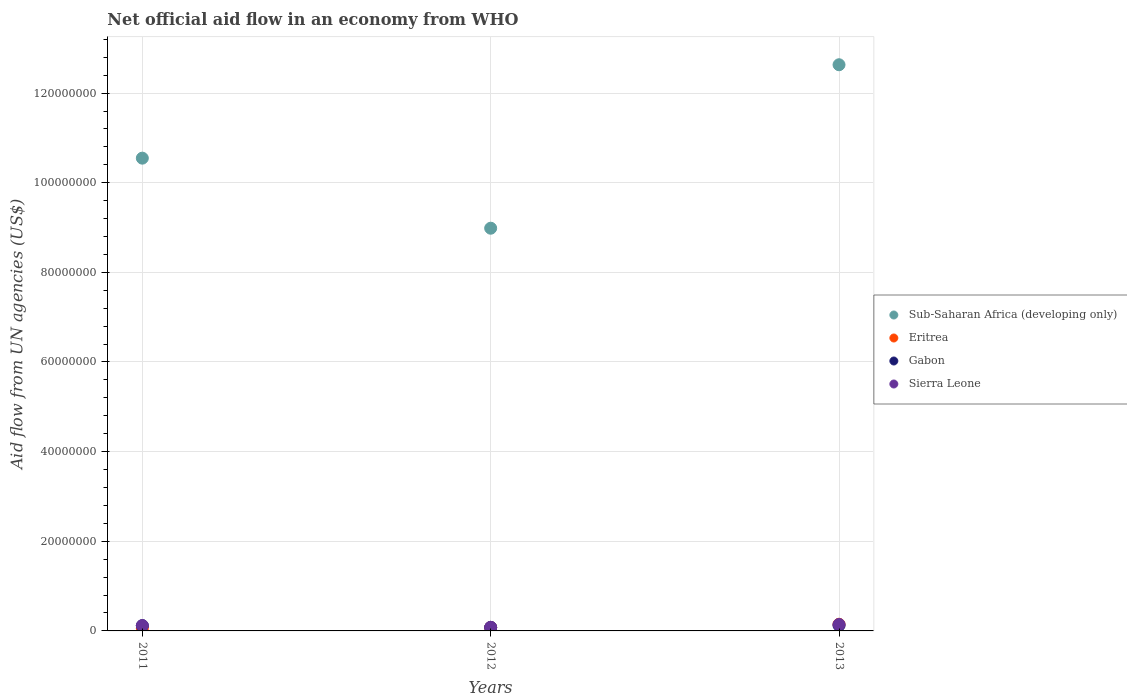Is the number of dotlines equal to the number of legend labels?
Offer a very short reply. Yes. What is the net official aid flow in Sub-Saharan Africa (developing only) in 2011?
Provide a succinct answer. 1.05e+08. Across all years, what is the maximum net official aid flow in Sub-Saharan Africa (developing only)?
Offer a terse response. 1.26e+08. Across all years, what is the minimum net official aid flow in Eritrea?
Your answer should be very brief. 6.00e+05. In which year was the net official aid flow in Sub-Saharan Africa (developing only) minimum?
Give a very brief answer. 2012. What is the total net official aid flow in Eritrea in the graph?
Keep it short and to the point. 2.86e+06. What is the difference between the net official aid flow in Gabon in 2012 and that in 2013?
Keep it short and to the point. -4.50e+05. What is the difference between the net official aid flow in Eritrea in 2011 and the net official aid flow in Sub-Saharan Africa (developing only) in 2013?
Your answer should be compact. -1.26e+08. What is the average net official aid flow in Gabon per year?
Make the answer very short. 1.07e+06. In the year 2011, what is the difference between the net official aid flow in Eritrea and net official aid flow in Gabon?
Offer a terse response. -5.70e+05. In how many years, is the net official aid flow in Sub-Saharan Africa (developing only) greater than 48000000 US$?
Your response must be concise. 3. What is the ratio of the net official aid flow in Eritrea in 2012 to that in 2013?
Your response must be concise. 0.52. What is the difference between the highest and the lowest net official aid flow in Sub-Saharan Africa (developing only)?
Offer a very short reply. 3.65e+07. Is the sum of the net official aid flow in Eritrea in 2011 and 2013 greater than the maximum net official aid flow in Sierra Leone across all years?
Offer a terse response. Yes. Is it the case that in every year, the sum of the net official aid flow in Sierra Leone and net official aid flow in Gabon  is greater than the sum of net official aid flow in Sub-Saharan Africa (developing only) and net official aid flow in Eritrea?
Offer a very short reply. No. Is the net official aid flow in Gabon strictly greater than the net official aid flow in Sierra Leone over the years?
Provide a succinct answer. No. Is the net official aid flow in Gabon strictly less than the net official aid flow in Sierra Leone over the years?
Your answer should be very brief. Yes. How many dotlines are there?
Provide a succinct answer. 4. Are the values on the major ticks of Y-axis written in scientific E-notation?
Ensure brevity in your answer.  No. What is the title of the graph?
Ensure brevity in your answer.  Net official aid flow in an economy from WHO. Does "Monaco" appear as one of the legend labels in the graph?
Offer a terse response. No. What is the label or title of the X-axis?
Keep it short and to the point. Years. What is the label or title of the Y-axis?
Your response must be concise. Aid flow from UN agencies (US$). What is the Aid flow from UN agencies (US$) of Sub-Saharan Africa (developing only) in 2011?
Your response must be concise. 1.05e+08. What is the Aid flow from UN agencies (US$) in Eritrea in 2011?
Offer a very short reply. 6.00e+05. What is the Aid flow from UN agencies (US$) in Gabon in 2011?
Offer a terse response. 1.17e+06. What is the Aid flow from UN agencies (US$) of Sierra Leone in 2011?
Your answer should be compact. 1.19e+06. What is the Aid flow from UN agencies (US$) of Sub-Saharan Africa (developing only) in 2012?
Your response must be concise. 8.98e+07. What is the Aid flow from UN agencies (US$) of Eritrea in 2012?
Your response must be concise. 7.70e+05. What is the Aid flow from UN agencies (US$) in Gabon in 2012?
Your answer should be compact. 7.90e+05. What is the Aid flow from UN agencies (US$) of Sub-Saharan Africa (developing only) in 2013?
Your answer should be compact. 1.26e+08. What is the Aid flow from UN agencies (US$) in Eritrea in 2013?
Make the answer very short. 1.49e+06. What is the Aid flow from UN agencies (US$) of Gabon in 2013?
Make the answer very short. 1.24e+06. What is the Aid flow from UN agencies (US$) of Sierra Leone in 2013?
Give a very brief answer. 1.44e+06. Across all years, what is the maximum Aid flow from UN agencies (US$) of Sub-Saharan Africa (developing only)?
Keep it short and to the point. 1.26e+08. Across all years, what is the maximum Aid flow from UN agencies (US$) of Eritrea?
Offer a very short reply. 1.49e+06. Across all years, what is the maximum Aid flow from UN agencies (US$) of Gabon?
Offer a terse response. 1.24e+06. Across all years, what is the maximum Aid flow from UN agencies (US$) of Sierra Leone?
Provide a succinct answer. 1.44e+06. Across all years, what is the minimum Aid flow from UN agencies (US$) of Sub-Saharan Africa (developing only)?
Your answer should be very brief. 8.98e+07. Across all years, what is the minimum Aid flow from UN agencies (US$) of Gabon?
Your answer should be very brief. 7.90e+05. Across all years, what is the minimum Aid flow from UN agencies (US$) in Sierra Leone?
Make the answer very short. 8.00e+05. What is the total Aid flow from UN agencies (US$) of Sub-Saharan Africa (developing only) in the graph?
Ensure brevity in your answer.  3.22e+08. What is the total Aid flow from UN agencies (US$) in Eritrea in the graph?
Provide a short and direct response. 2.86e+06. What is the total Aid flow from UN agencies (US$) of Gabon in the graph?
Your response must be concise. 3.20e+06. What is the total Aid flow from UN agencies (US$) of Sierra Leone in the graph?
Provide a short and direct response. 3.43e+06. What is the difference between the Aid flow from UN agencies (US$) in Sub-Saharan Africa (developing only) in 2011 and that in 2012?
Keep it short and to the point. 1.56e+07. What is the difference between the Aid flow from UN agencies (US$) in Gabon in 2011 and that in 2012?
Provide a succinct answer. 3.80e+05. What is the difference between the Aid flow from UN agencies (US$) in Sub-Saharan Africa (developing only) in 2011 and that in 2013?
Offer a very short reply. -2.08e+07. What is the difference between the Aid flow from UN agencies (US$) in Eritrea in 2011 and that in 2013?
Your answer should be very brief. -8.90e+05. What is the difference between the Aid flow from UN agencies (US$) in Gabon in 2011 and that in 2013?
Offer a very short reply. -7.00e+04. What is the difference between the Aid flow from UN agencies (US$) in Sierra Leone in 2011 and that in 2013?
Make the answer very short. -2.50e+05. What is the difference between the Aid flow from UN agencies (US$) of Sub-Saharan Africa (developing only) in 2012 and that in 2013?
Make the answer very short. -3.65e+07. What is the difference between the Aid flow from UN agencies (US$) in Eritrea in 2012 and that in 2013?
Make the answer very short. -7.20e+05. What is the difference between the Aid flow from UN agencies (US$) in Gabon in 2012 and that in 2013?
Ensure brevity in your answer.  -4.50e+05. What is the difference between the Aid flow from UN agencies (US$) of Sierra Leone in 2012 and that in 2013?
Provide a succinct answer. -6.40e+05. What is the difference between the Aid flow from UN agencies (US$) of Sub-Saharan Africa (developing only) in 2011 and the Aid flow from UN agencies (US$) of Eritrea in 2012?
Offer a terse response. 1.05e+08. What is the difference between the Aid flow from UN agencies (US$) in Sub-Saharan Africa (developing only) in 2011 and the Aid flow from UN agencies (US$) in Gabon in 2012?
Offer a terse response. 1.05e+08. What is the difference between the Aid flow from UN agencies (US$) in Sub-Saharan Africa (developing only) in 2011 and the Aid flow from UN agencies (US$) in Sierra Leone in 2012?
Your answer should be very brief. 1.05e+08. What is the difference between the Aid flow from UN agencies (US$) of Eritrea in 2011 and the Aid flow from UN agencies (US$) of Gabon in 2012?
Offer a terse response. -1.90e+05. What is the difference between the Aid flow from UN agencies (US$) in Eritrea in 2011 and the Aid flow from UN agencies (US$) in Sierra Leone in 2012?
Offer a terse response. -2.00e+05. What is the difference between the Aid flow from UN agencies (US$) of Sub-Saharan Africa (developing only) in 2011 and the Aid flow from UN agencies (US$) of Eritrea in 2013?
Provide a succinct answer. 1.04e+08. What is the difference between the Aid flow from UN agencies (US$) of Sub-Saharan Africa (developing only) in 2011 and the Aid flow from UN agencies (US$) of Gabon in 2013?
Offer a very short reply. 1.04e+08. What is the difference between the Aid flow from UN agencies (US$) of Sub-Saharan Africa (developing only) in 2011 and the Aid flow from UN agencies (US$) of Sierra Leone in 2013?
Ensure brevity in your answer.  1.04e+08. What is the difference between the Aid flow from UN agencies (US$) in Eritrea in 2011 and the Aid flow from UN agencies (US$) in Gabon in 2013?
Ensure brevity in your answer.  -6.40e+05. What is the difference between the Aid flow from UN agencies (US$) in Eritrea in 2011 and the Aid flow from UN agencies (US$) in Sierra Leone in 2013?
Your answer should be compact. -8.40e+05. What is the difference between the Aid flow from UN agencies (US$) of Gabon in 2011 and the Aid flow from UN agencies (US$) of Sierra Leone in 2013?
Offer a terse response. -2.70e+05. What is the difference between the Aid flow from UN agencies (US$) of Sub-Saharan Africa (developing only) in 2012 and the Aid flow from UN agencies (US$) of Eritrea in 2013?
Your response must be concise. 8.84e+07. What is the difference between the Aid flow from UN agencies (US$) in Sub-Saharan Africa (developing only) in 2012 and the Aid flow from UN agencies (US$) in Gabon in 2013?
Make the answer very short. 8.86e+07. What is the difference between the Aid flow from UN agencies (US$) of Sub-Saharan Africa (developing only) in 2012 and the Aid flow from UN agencies (US$) of Sierra Leone in 2013?
Keep it short and to the point. 8.84e+07. What is the difference between the Aid flow from UN agencies (US$) of Eritrea in 2012 and the Aid flow from UN agencies (US$) of Gabon in 2013?
Your answer should be compact. -4.70e+05. What is the difference between the Aid flow from UN agencies (US$) in Eritrea in 2012 and the Aid flow from UN agencies (US$) in Sierra Leone in 2013?
Provide a short and direct response. -6.70e+05. What is the difference between the Aid flow from UN agencies (US$) of Gabon in 2012 and the Aid flow from UN agencies (US$) of Sierra Leone in 2013?
Offer a very short reply. -6.50e+05. What is the average Aid flow from UN agencies (US$) of Sub-Saharan Africa (developing only) per year?
Your answer should be very brief. 1.07e+08. What is the average Aid flow from UN agencies (US$) in Eritrea per year?
Ensure brevity in your answer.  9.53e+05. What is the average Aid flow from UN agencies (US$) of Gabon per year?
Offer a very short reply. 1.07e+06. What is the average Aid flow from UN agencies (US$) of Sierra Leone per year?
Provide a succinct answer. 1.14e+06. In the year 2011, what is the difference between the Aid flow from UN agencies (US$) of Sub-Saharan Africa (developing only) and Aid flow from UN agencies (US$) of Eritrea?
Your answer should be very brief. 1.05e+08. In the year 2011, what is the difference between the Aid flow from UN agencies (US$) in Sub-Saharan Africa (developing only) and Aid flow from UN agencies (US$) in Gabon?
Your answer should be very brief. 1.04e+08. In the year 2011, what is the difference between the Aid flow from UN agencies (US$) in Sub-Saharan Africa (developing only) and Aid flow from UN agencies (US$) in Sierra Leone?
Provide a short and direct response. 1.04e+08. In the year 2011, what is the difference between the Aid flow from UN agencies (US$) in Eritrea and Aid flow from UN agencies (US$) in Gabon?
Make the answer very short. -5.70e+05. In the year 2011, what is the difference between the Aid flow from UN agencies (US$) in Eritrea and Aid flow from UN agencies (US$) in Sierra Leone?
Make the answer very short. -5.90e+05. In the year 2012, what is the difference between the Aid flow from UN agencies (US$) of Sub-Saharan Africa (developing only) and Aid flow from UN agencies (US$) of Eritrea?
Give a very brief answer. 8.91e+07. In the year 2012, what is the difference between the Aid flow from UN agencies (US$) of Sub-Saharan Africa (developing only) and Aid flow from UN agencies (US$) of Gabon?
Make the answer very short. 8.91e+07. In the year 2012, what is the difference between the Aid flow from UN agencies (US$) of Sub-Saharan Africa (developing only) and Aid flow from UN agencies (US$) of Sierra Leone?
Ensure brevity in your answer.  8.90e+07. In the year 2013, what is the difference between the Aid flow from UN agencies (US$) of Sub-Saharan Africa (developing only) and Aid flow from UN agencies (US$) of Eritrea?
Your answer should be very brief. 1.25e+08. In the year 2013, what is the difference between the Aid flow from UN agencies (US$) in Sub-Saharan Africa (developing only) and Aid flow from UN agencies (US$) in Gabon?
Offer a terse response. 1.25e+08. In the year 2013, what is the difference between the Aid flow from UN agencies (US$) of Sub-Saharan Africa (developing only) and Aid flow from UN agencies (US$) of Sierra Leone?
Ensure brevity in your answer.  1.25e+08. In the year 2013, what is the difference between the Aid flow from UN agencies (US$) in Eritrea and Aid flow from UN agencies (US$) in Gabon?
Provide a short and direct response. 2.50e+05. In the year 2013, what is the difference between the Aid flow from UN agencies (US$) of Eritrea and Aid flow from UN agencies (US$) of Sierra Leone?
Your answer should be very brief. 5.00e+04. In the year 2013, what is the difference between the Aid flow from UN agencies (US$) of Gabon and Aid flow from UN agencies (US$) of Sierra Leone?
Make the answer very short. -2.00e+05. What is the ratio of the Aid flow from UN agencies (US$) of Sub-Saharan Africa (developing only) in 2011 to that in 2012?
Your answer should be very brief. 1.17. What is the ratio of the Aid flow from UN agencies (US$) in Eritrea in 2011 to that in 2012?
Make the answer very short. 0.78. What is the ratio of the Aid flow from UN agencies (US$) in Gabon in 2011 to that in 2012?
Give a very brief answer. 1.48. What is the ratio of the Aid flow from UN agencies (US$) of Sierra Leone in 2011 to that in 2012?
Your answer should be very brief. 1.49. What is the ratio of the Aid flow from UN agencies (US$) of Sub-Saharan Africa (developing only) in 2011 to that in 2013?
Provide a succinct answer. 0.83. What is the ratio of the Aid flow from UN agencies (US$) of Eritrea in 2011 to that in 2013?
Offer a terse response. 0.4. What is the ratio of the Aid flow from UN agencies (US$) in Gabon in 2011 to that in 2013?
Offer a very short reply. 0.94. What is the ratio of the Aid flow from UN agencies (US$) in Sierra Leone in 2011 to that in 2013?
Keep it short and to the point. 0.83. What is the ratio of the Aid flow from UN agencies (US$) in Sub-Saharan Africa (developing only) in 2012 to that in 2013?
Provide a succinct answer. 0.71. What is the ratio of the Aid flow from UN agencies (US$) in Eritrea in 2012 to that in 2013?
Offer a very short reply. 0.52. What is the ratio of the Aid flow from UN agencies (US$) in Gabon in 2012 to that in 2013?
Provide a succinct answer. 0.64. What is the ratio of the Aid flow from UN agencies (US$) in Sierra Leone in 2012 to that in 2013?
Your answer should be very brief. 0.56. What is the difference between the highest and the second highest Aid flow from UN agencies (US$) in Sub-Saharan Africa (developing only)?
Offer a very short reply. 2.08e+07. What is the difference between the highest and the second highest Aid flow from UN agencies (US$) of Eritrea?
Your answer should be very brief. 7.20e+05. What is the difference between the highest and the lowest Aid flow from UN agencies (US$) of Sub-Saharan Africa (developing only)?
Provide a short and direct response. 3.65e+07. What is the difference between the highest and the lowest Aid flow from UN agencies (US$) of Eritrea?
Offer a very short reply. 8.90e+05. What is the difference between the highest and the lowest Aid flow from UN agencies (US$) in Sierra Leone?
Offer a terse response. 6.40e+05. 